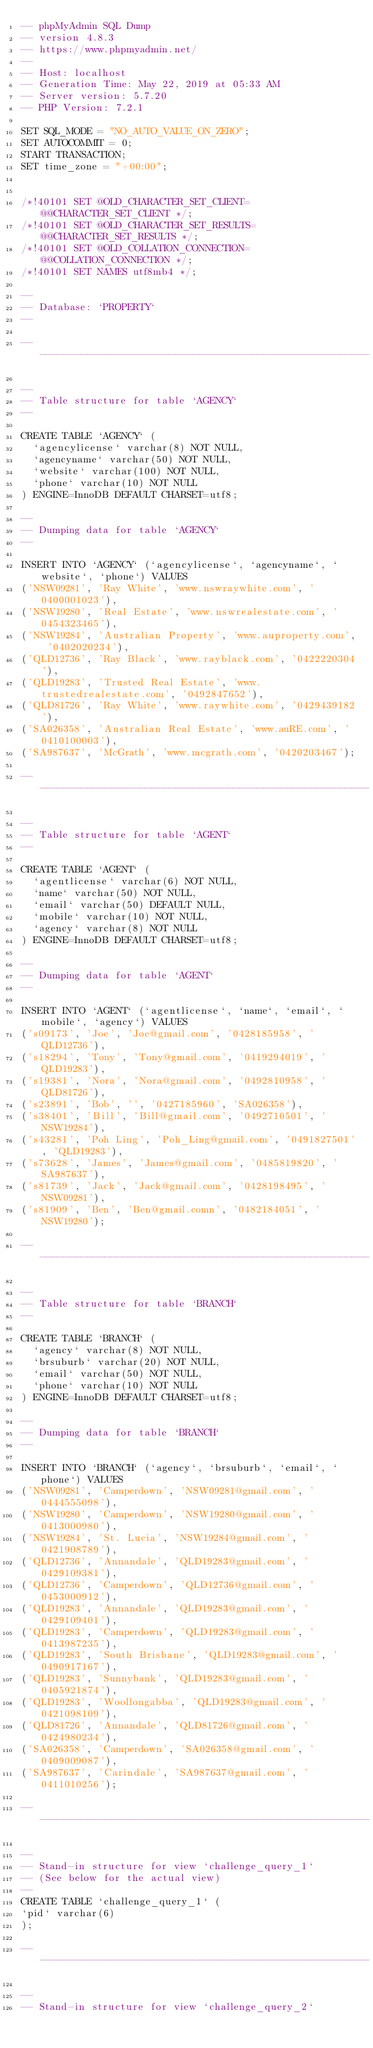<code> <loc_0><loc_0><loc_500><loc_500><_SQL_>-- phpMyAdmin SQL Dump
-- version 4.8.3
-- https://www.phpmyadmin.net/
--
-- Host: localhost
-- Generation Time: May 22, 2019 at 05:33 AM
-- Server version: 5.7.20
-- PHP Version: 7.2.1

SET SQL_MODE = "NO_AUTO_VALUE_ON_ZERO";
SET AUTOCOMMIT = 0;
START TRANSACTION;
SET time_zone = "+00:00";


/*!40101 SET @OLD_CHARACTER_SET_CLIENT=@@CHARACTER_SET_CLIENT */;
/*!40101 SET @OLD_CHARACTER_SET_RESULTS=@@CHARACTER_SET_RESULTS */;
/*!40101 SET @OLD_COLLATION_CONNECTION=@@COLLATION_CONNECTION */;
/*!40101 SET NAMES utf8mb4 */;

--
-- Database: `PROPERTY`
--

-- --------------------------------------------------------

--
-- Table structure for table `AGENCY`
--

CREATE TABLE `AGENCY` (
  `agencylicense` varchar(8) NOT NULL,
  `agencyname` varchar(50) NOT NULL,
  `website` varchar(100) NOT NULL,
  `phone` varchar(10) NOT NULL
) ENGINE=InnoDB DEFAULT CHARSET=utf8;

--
-- Dumping data for table `AGENCY`
--

INSERT INTO `AGENCY` (`agencylicense`, `agencyname`, `website`, `phone`) VALUES
('NSW09281', 'Ray White', 'www.nswraywhite.com', '0400001023'),
('NSW19280', 'Real Estate', 'www.nswrealestate.com', '0454323465'),
('NSW19284', 'Australian Property', 'www.auproperty.com', '0402020234'),
('QLD12736', 'Ray Black', 'www.rayblack.com', '0422220304'),
('QLD19283', 'Trusted Real Estate', 'www.trustedrealestate.com', '0492847652'),
('QLD81726', 'Ray White', 'www.raywhite.com', '0429439182'),
('SA026358', 'Australian Real Estate', 'www.auRE.com', '0410100003'),
('SA987637', 'McGrath', 'www.mcgrath.com', '0420203467');

-- --------------------------------------------------------

--
-- Table structure for table `AGENT`
--

CREATE TABLE `AGENT` (
  `agentlicense` varchar(6) NOT NULL,
  `name` varchar(50) NOT NULL,
  `email` varchar(50) DEFAULT NULL,
  `mobile` varchar(10) NOT NULL,
  `agency` varchar(8) NOT NULL
) ENGINE=InnoDB DEFAULT CHARSET=utf8;

--
-- Dumping data for table `AGENT`
--

INSERT INTO `AGENT` (`agentlicense`, `name`, `email`, `mobile`, `agency`) VALUES
('s09173', 'Joe', 'Joe@gmail.com', '0428185958', 'QLD12736'),
('s18294', 'Tony', 'Tony@gmail.com', '0419294019', 'QLD19283'),
('s19381', 'Nora', 'Nora@gmail.com', '0492810958', 'QLD81726'),
('s23891', 'Bob', '', '0427185960', 'SA026358'),
('s38401', 'Bill', 'Bill@gmail.com', '0492710501', 'NSW19284'),
('s43281', 'Poh Ling', 'Poh_Ling@gmail.com', '0491827501', 'QLD19283'),
('s73628', 'James', 'James@gmail.com', '0485819820', 'SA987637'),
('s81739', 'Jack', 'Jack@gmail.com', '0428198495', 'NSW09281'),
('s81909', 'Ben', 'Ben@gmail.comn', '0482184051', 'NSW19280');

-- --------------------------------------------------------

--
-- Table structure for table `BRANCH`
--

CREATE TABLE `BRANCH` (
  `agency` varchar(8) NOT NULL,
  `brsuburb` varchar(20) NOT NULL,
  `email` varchar(50) NOT NULL,
  `phone` varchar(10) NOT NULL
) ENGINE=InnoDB DEFAULT CHARSET=utf8;

--
-- Dumping data for table `BRANCH`
--

INSERT INTO `BRANCH` (`agency`, `brsuburb`, `email`, `phone`) VALUES
('NSW09281', 'Camperdown', 'NSW09281@gmail.com', '0444555098'),
('NSW19280', 'Camperdown', 'NSW19280@gmail.com', '0413000980'),
('NSW19284', 'St. Lucia', 'NSW19284@gmail.com', '0421908789'),
('QLD12736', 'Annandale', 'QLD19283@gmail.com', '0429109381'),
('QLD12736', 'Camperdown', 'QLD12736@gmail.com', '0453000912'),
('QLD19283', 'Annandale', 'QLD19283@gmail.com', '0429109401'),
('QLD19283', 'Camperdown', 'QLD19283@gmail.com', '0413987235'),
('QLD19283', 'South Brisbane', 'QLD19283@gmail.com', '0490917167'),
('QLD19283', 'Sunnybank', 'QLD19283@gmail.com', '0405921874'),
('QLD19283', 'Woollongabba', 'QLD19283@gmail.com', '0421098109'),
('QLD81726', 'Annandale', 'QLD81726@gmail.com', '0424980234'),
('SA026358', 'Camperdown', 'SA026358@gmail.com', '0409009087'),
('SA987637', 'Carindale', 'SA987637@gmail.com', '0411010256');

-- --------------------------------------------------------

--
-- Stand-in structure for view `challenge_query_1`
-- (See below for the actual view)
--
CREATE TABLE `challenge_query_1` (
`pid` varchar(6)
);

-- --------------------------------------------------------

--
-- Stand-in structure for view `challenge_query_2`</code> 